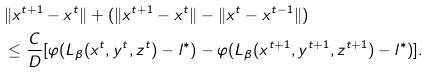<formula> <loc_0><loc_0><loc_500><loc_500>& \| x ^ { t + 1 } - x ^ { t } \| + ( \| x ^ { t + 1 } - x ^ { t } \| - \| x ^ { t } - x ^ { t - 1 } \| ) \\ & \leq \frac { C } { D } [ \varphi ( L _ { \beta } ( x ^ { t } , y ^ { t } , z ^ { t } ) - l ^ { * } ) - \varphi ( L _ { \beta } ( x ^ { t + 1 } , y ^ { t + 1 } , z ^ { t + 1 } ) - l ^ { * } ) ] .</formula> 